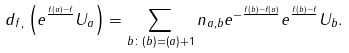Convert formula to latex. <formula><loc_0><loc_0><loc_500><loc_500>d _ { f , } \left ( e ^ { \frac { f ( a ) - f } { } } U _ { a } \right ) = \sum _ { b \colon ( b ) = ( a ) + 1 } n _ { a , b } e ^ { - \frac { f ( b ) - f ( a ) } { } } e ^ { \frac { f ( b ) - f } { } } U _ { b } .</formula> 